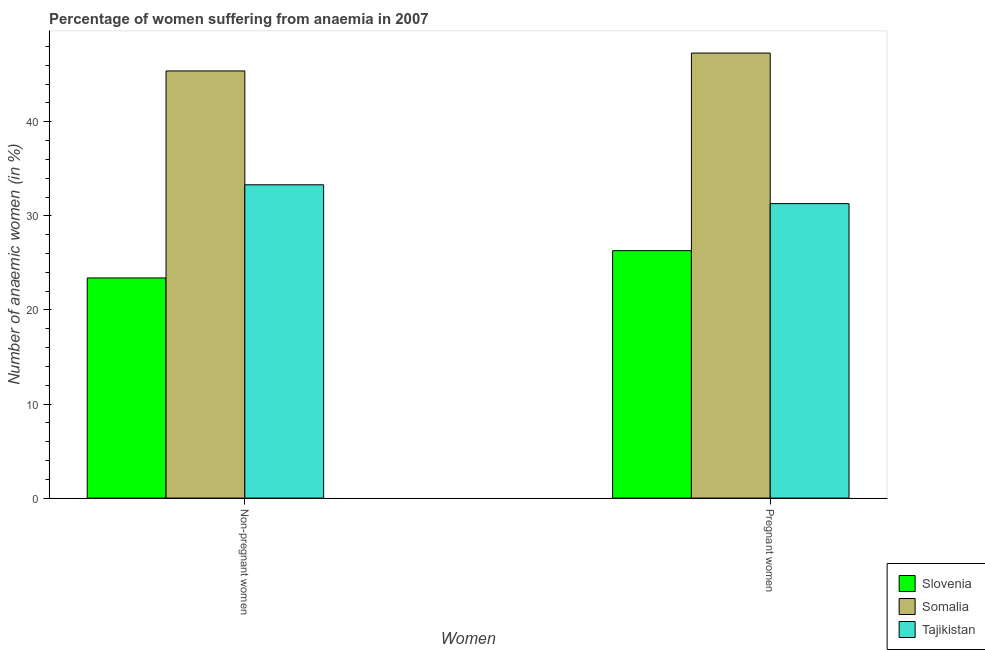How many different coloured bars are there?
Offer a very short reply. 3. Are the number of bars per tick equal to the number of legend labels?
Keep it short and to the point. Yes. Are the number of bars on each tick of the X-axis equal?
Provide a short and direct response. Yes. How many bars are there on the 2nd tick from the left?
Keep it short and to the point. 3. What is the label of the 1st group of bars from the left?
Your response must be concise. Non-pregnant women. What is the percentage of pregnant anaemic women in Somalia?
Give a very brief answer. 47.3. Across all countries, what is the maximum percentage of non-pregnant anaemic women?
Your response must be concise. 45.4. Across all countries, what is the minimum percentage of pregnant anaemic women?
Provide a succinct answer. 26.3. In which country was the percentage of pregnant anaemic women maximum?
Keep it short and to the point. Somalia. In which country was the percentage of pregnant anaemic women minimum?
Your response must be concise. Slovenia. What is the total percentage of non-pregnant anaemic women in the graph?
Offer a terse response. 102.1. What is the difference between the percentage of non-pregnant anaemic women in Somalia and that in Tajikistan?
Your answer should be compact. 12.1. What is the difference between the percentage of pregnant anaemic women in Tajikistan and the percentage of non-pregnant anaemic women in Somalia?
Provide a short and direct response. -14.1. What is the average percentage of pregnant anaemic women per country?
Your answer should be compact. 34.97. What is the difference between the percentage of pregnant anaemic women and percentage of non-pregnant anaemic women in Slovenia?
Ensure brevity in your answer.  2.9. What is the ratio of the percentage of non-pregnant anaemic women in Tajikistan to that in Slovenia?
Your response must be concise. 1.42. In how many countries, is the percentage of pregnant anaemic women greater than the average percentage of pregnant anaemic women taken over all countries?
Ensure brevity in your answer.  1. What does the 3rd bar from the left in Pregnant women represents?
Keep it short and to the point. Tajikistan. What does the 3rd bar from the right in Non-pregnant women represents?
Your answer should be very brief. Slovenia. What is the difference between two consecutive major ticks on the Y-axis?
Provide a succinct answer. 10. Are the values on the major ticks of Y-axis written in scientific E-notation?
Offer a very short reply. No. Does the graph contain any zero values?
Ensure brevity in your answer.  No. Does the graph contain grids?
Your response must be concise. No. What is the title of the graph?
Your answer should be very brief. Percentage of women suffering from anaemia in 2007. What is the label or title of the X-axis?
Your answer should be compact. Women. What is the label or title of the Y-axis?
Give a very brief answer. Number of anaemic women (in %). What is the Number of anaemic women (in %) of Slovenia in Non-pregnant women?
Offer a terse response. 23.4. What is the Number of anaemic women (in %) in Somalia in Non-pregnant women?
Your response must be concise. 45.4. What is the Number of anaemic women (in %) in Tajikistan in Non-pregnant women?
Keep it short and to the point. 33.3. What is the Number of anaemic women (in %) of Slovenia in Pregnant women?
Provide a short and direct response. 26.3. What is the Number of anaemic women (in %) of Somalia in Pregnant women?
Your response must be concise. 47.3. What is the Number of anaemic women (in %) of Tajikistan in Pregnant women?
Your answer should be very brief. 31.3. Across all Women, what is the maximum Number of anaemic women (in %) in Slovenia?
Your response must be concise. 26.3. Across all Women, what is the maximum Number of anaemic women (in %) of Somalia?
Make the answer very short. 47.3. Across all Women, what is the maximum Number of anaemic women (in %) of Tajikistan?
Your response must be concise. 33.3. Across all Women, what is the minimum Number of anaemic women (in %) of Slovenia?
Give a very brief answer. 23.4. Across all Women, what is the minimum Number of anaemic women (in %) of Somalia?
Provide a succinct answer. 45.4. Across all Women, what is the minimum Number of anaemic women (in %) in Tajikistan?
Your response must be concise. 31.3. What is the total Number of anaemic women (in %) of Slovenia in the graph?
Make the answer very short. 49.7. What is the total Number of anaemic women (in %) in Somalia in the graph?
Your response must be concise. 92.7. What is the total Number of anaemic women (in %) of Tajikistan in the graph?
Offer a very short reply. 64.6. What is the difference between the Number of anaemic women (in %) of Slovenia in Non-pregnant women and that in Pregnant women?
Ensure brevity in your answer.  -2.9. What is the difference between the Number of anaemic women (in %) in Slovenia in Non-pregnant women and the Number of anaemic women (in %) in Somalia in Pregnant women?
Offer a very short reply. -23.9. What is the difference between the Number of anaemic women (in %) of Somalia in Non-pregnant women and the Number of anaemic women (in %) of Tajikistan in Pregnant women?
Provide a short and direct response. 14.1. What is the average Number of anaemic women (in %) of Slovenia per Women?
Your response must be concise. 24.85. What is the average Number of anaemic women (in %) in Somalia per Women?
Your answer should be compact. 46.35. What is the average Number of anaemic women (in %) of Tajikistan per Women?
Give a very brief answer. 32.3. What is the difference between the Number of anaemic women (in %) of Slovenia and Number of anaemic women (in %) of Tajikistan in Non-pregnant women?
Offer a terse response. -9.9. What is the difference between the Number of anaemic women (in %) of Slovenia and Number of anaemic women (in %) of Somalia in Pregnant women?
Give a very brief answer. -21. What is the difference between the Number of anaemic women (in %) in Slovenia and Number of anaemic women (in %) in Tajikistan in Pregnant women?
Ensure brevity in your answer.  -5. What is the difference between the Number of anaemic women (in %) in Somalia and Number of anaemic women (in %) in Tajikistan in Pregnant women?
Give a very brief answer. 16. What is the ratio of the Number of anaemic women (in %) of Slovenia in Non-pregnant women to that in Pregnant women?
Your answer should be compact. 0.89. What is the ratio of the Number of anaemic women (in %) in Somalia in Non-pregnant women to that in Pregnant women?
Give a very brief answer. 0.96. What is the ratio of the Number of anaemic women (in %) in Tajikistan in Non-pregnant women to that in Pregnant women?
Ensure brevity in your answer.  1.06. What is the difference between the highest and the second highest Number of anaemic women (in %) in Somalia?
Provide a succinct answer. 1.9. What is the difference between the highest and the second highest Number of anaemic women (in %) of Tajikistan?
Give a very brief answer. 2. What is the difference between the highest and the lowest Number of anaemic women (in %) in Slovenia?
Your response must be concise. 2.9. 